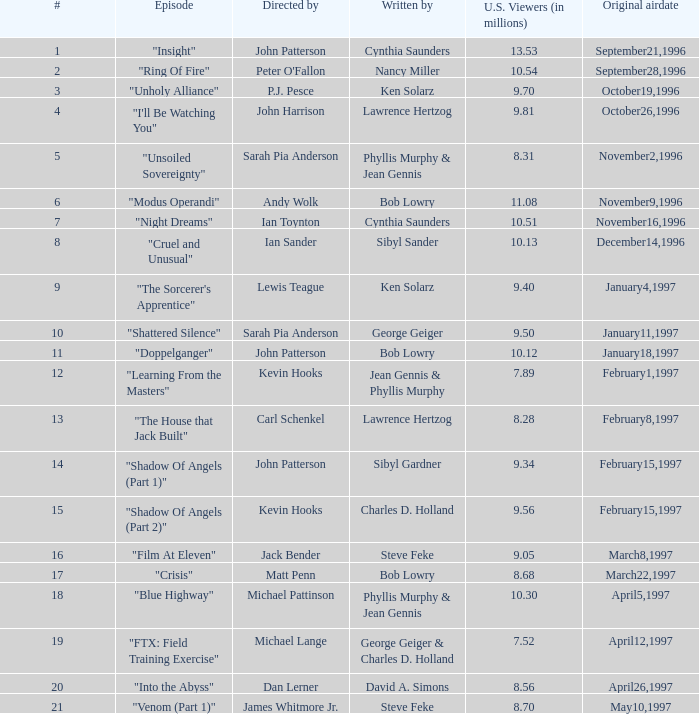52 million us audience? George Geiger & Charles D. Holland. 